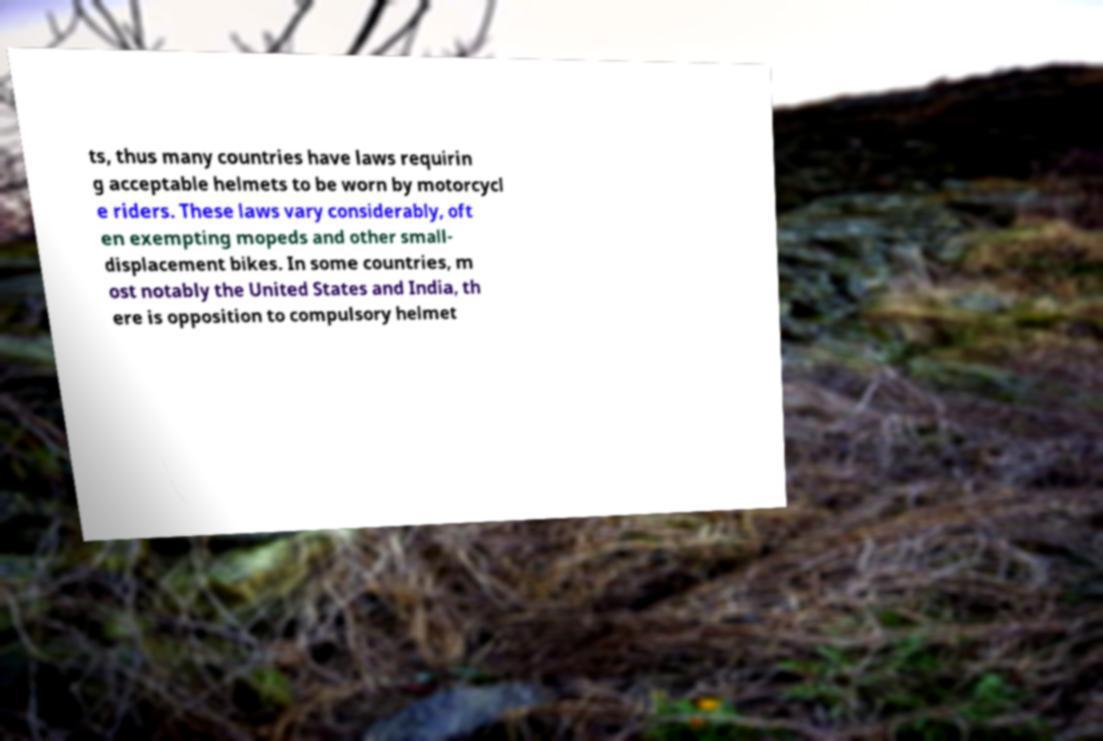Please read and relay the text visible in this image. What does it say? ts, thus many countries have laws requirin g acceptable helmets to be worn by motorcycl e riders. These laws vary considerably, oft en exempting mopeds and other small- displacement bikes. In some countries, m ost notably the United States and India, th ere is opposition to compulsory helmet 